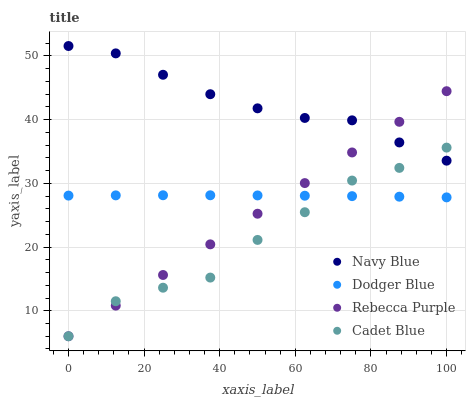Does Cadet Blue have the minimum area under the curve?
Answer yes or no. Yes. Does Navy Blue have the maximum area under the curve?
Answer yes or no. Yes. Does Dodger Blue have the minimum area under the curve?
Answer yes or no. No. Does Dodger Blue have the maximum area under the curve?
Answer yes or no. No. Is Rebecca Purple the smoothest?
Answer yes or no. Yes. Is Cadet Blue the roughest?
Answer yes or no. Yes. Is Dodger Blue the smoothest?
Answer yes or no. No. Is Dodger Blue the roughest?
Answer yes or no. No. Does Cadet Blue have the lowest value?
Answer yes or no. Yes. Does Dodger Blue have the lowest value?
Answer yes or no. No. Does Navy Blue have the highest value?
Answer yes or no. Yes. Does Cadet Blue have the highest value?
Answer yes or no. No. Is Dodger Blue less than Navy Blue?
Answer yes or no. Yes. Is Navy Blue greater than Dodger Blue?
Answer yes or no. Yes. Does Rebecca Purple intersect Dodger Blue?
Answer yes or no. Yes. Is Rebecca Purple less than Dodger Blue?
Answer yes or no. No. Is Rebecca Purple greater than Dodger Blue?
Answer yes or no. No. Does Dodger Blue intersect Navy Blue?
Answer yes or no. No. 